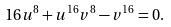Convert formula to latex. <formula><loc_0><loc_0><loc_500><loc_500>1 6 u ^ { 8 } + u ^ { 1 6 } v ^ { 8 } - v ^ { 1 6 } = 0 .</formula> 